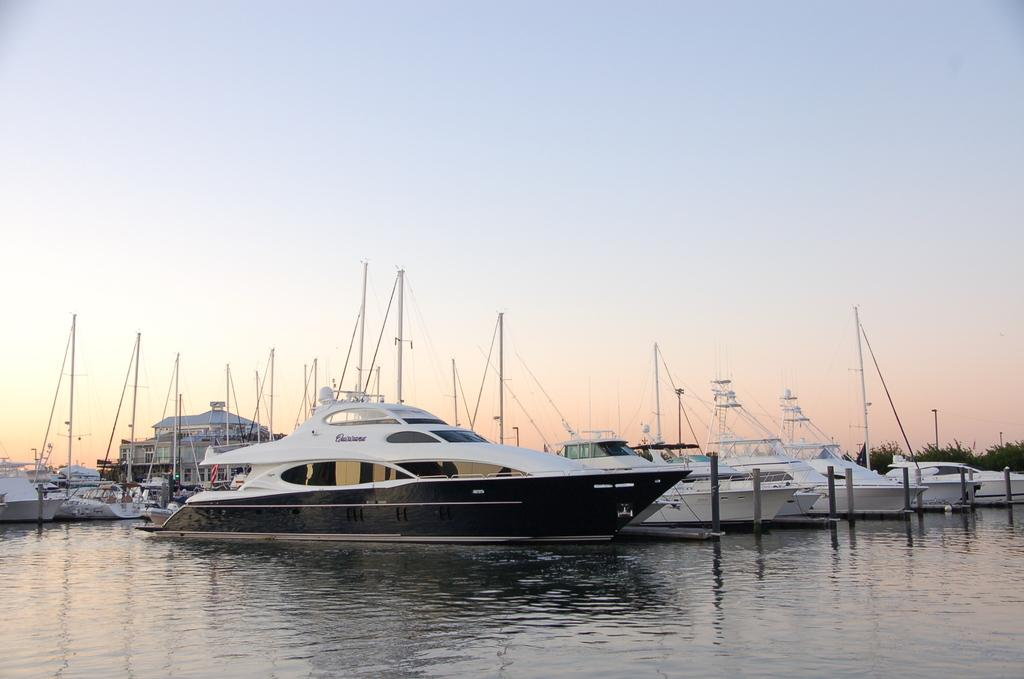What type of vehicles are in the image? There are boats in the image. What is at the bottom of the image? There is water at the bottom of the image. What can be seen in the background of the image? There are trees in the background of the image. What is visible at the top of the image? The sky is visible at the top of the image. How many hands are visible holding the boats in the image? There are no hands visible holding the boats in the image. What type of watch can be seen on the wrist of the person in the boat? There is no person or watch present in the image. 